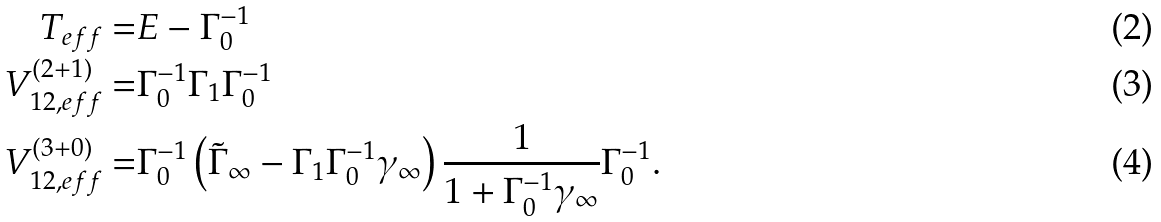Convert formula to latex. <formula><loc_0><loc_0><loc_500><loc_500>T _ { e f f } = & E - \Gamma _ { 0 } ^ { - 1 } \\ V ^ { ( 2 + 1 ) } _ { 1 2 , e f f } = & \Gamma _ { 0 } ^ { - 1 } \Gamma _ { 1 } \Gamma _ { 0 } ^ { - 1 } \\ V ^ { ( 3 + 0 ) } _ { 1 2 , e f f } = & \Gamma _ { 0 } ^ { - 1 } \left ( \tilde { \Gamma } _ { \infty } - \Gamma _ { 1 } \Gamma _ { 0 } ^ { - 1 } \gamma _ { \infty } \right ) \frac { 1 } { 1 + \Gamma _ { 0 } ^ { - 1 } \gamma _ { \infty } } \Gamma _ { 0 } ^ { - 1 } .</formula> 